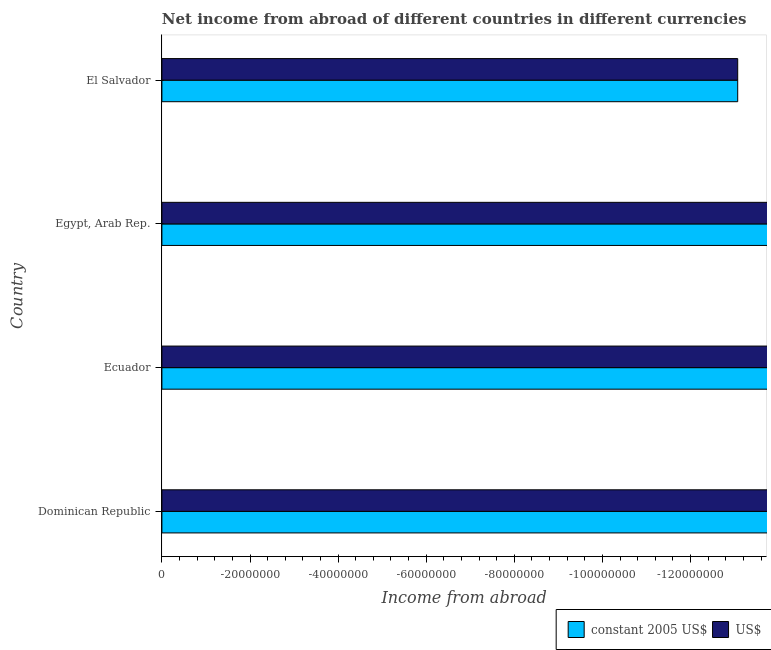Are the number of bars per tick equal to the number of legend labels?
Offer a very short reply. No. How many bars are there on the 3rd tick from the top?
Your answer should be compact. 0. What is the label of the 2nd group of bars from the top?
Your answer should be compact. Egypt, Arab Rep. What is the total income from abroad in us$ in the graph?
Provide a short and direct response. 0. What is the difference between the income from abroad in constant 2005 us$ in Egypt, Arab Rep. and the income from abroad in us$ in El Salvador?
Your answer should be very brief. 0. In how many countries, is the income from abroad in constant 2005 us$ greater than the average income from abroad in constant 2005 us$ taken over all countries?
Provide a short and direct response. 0. Are all the bars in the graph horizontal?
Offer a terse response. Yes. Are the values on the major ticks of X-axis written in scientific E-notation?
Keep it short and to the point. No. Does the graph contain any zero values?
Your answer should be very brief. Yes. Does the graph contain grids?
Make the answer very short. No. Where does the legend appear in the graph?
Provide a succinct answer. Bottom right. How many legend labels are there?
Make the answer very short. 2. What is the title of the graph?
Give a very brief answer. Net income from abroad of different countries in different currencies. Does "Female labor force" appear as one of the legend labels in the graph?
Offer a terse response. No. What is the label or title of the X-axis?
Your answer should be compact. Income from abroad. What is the label or title of the Y-axis?
Make the answer very short. Country. What is the Income from abroad of constant 2005 US$ in Dominican Republic?
Provide a succinct answer. 0. What is the Income from abroad in US$ in Dominican Republic?
Offer a very short reply. 0. What is the Income from abroad of US$ in Ecuador?
Your answer should be very brief. 0. What is the total Income from abroad in US$ in the graph?
Give a very brief answer. 0. What is the average Income from abroad in constant 2005 US$ per country?
Offer a very short reply. 0. What is the average Income from abroad in US$ per country?
Offer a very short reply. 0. 